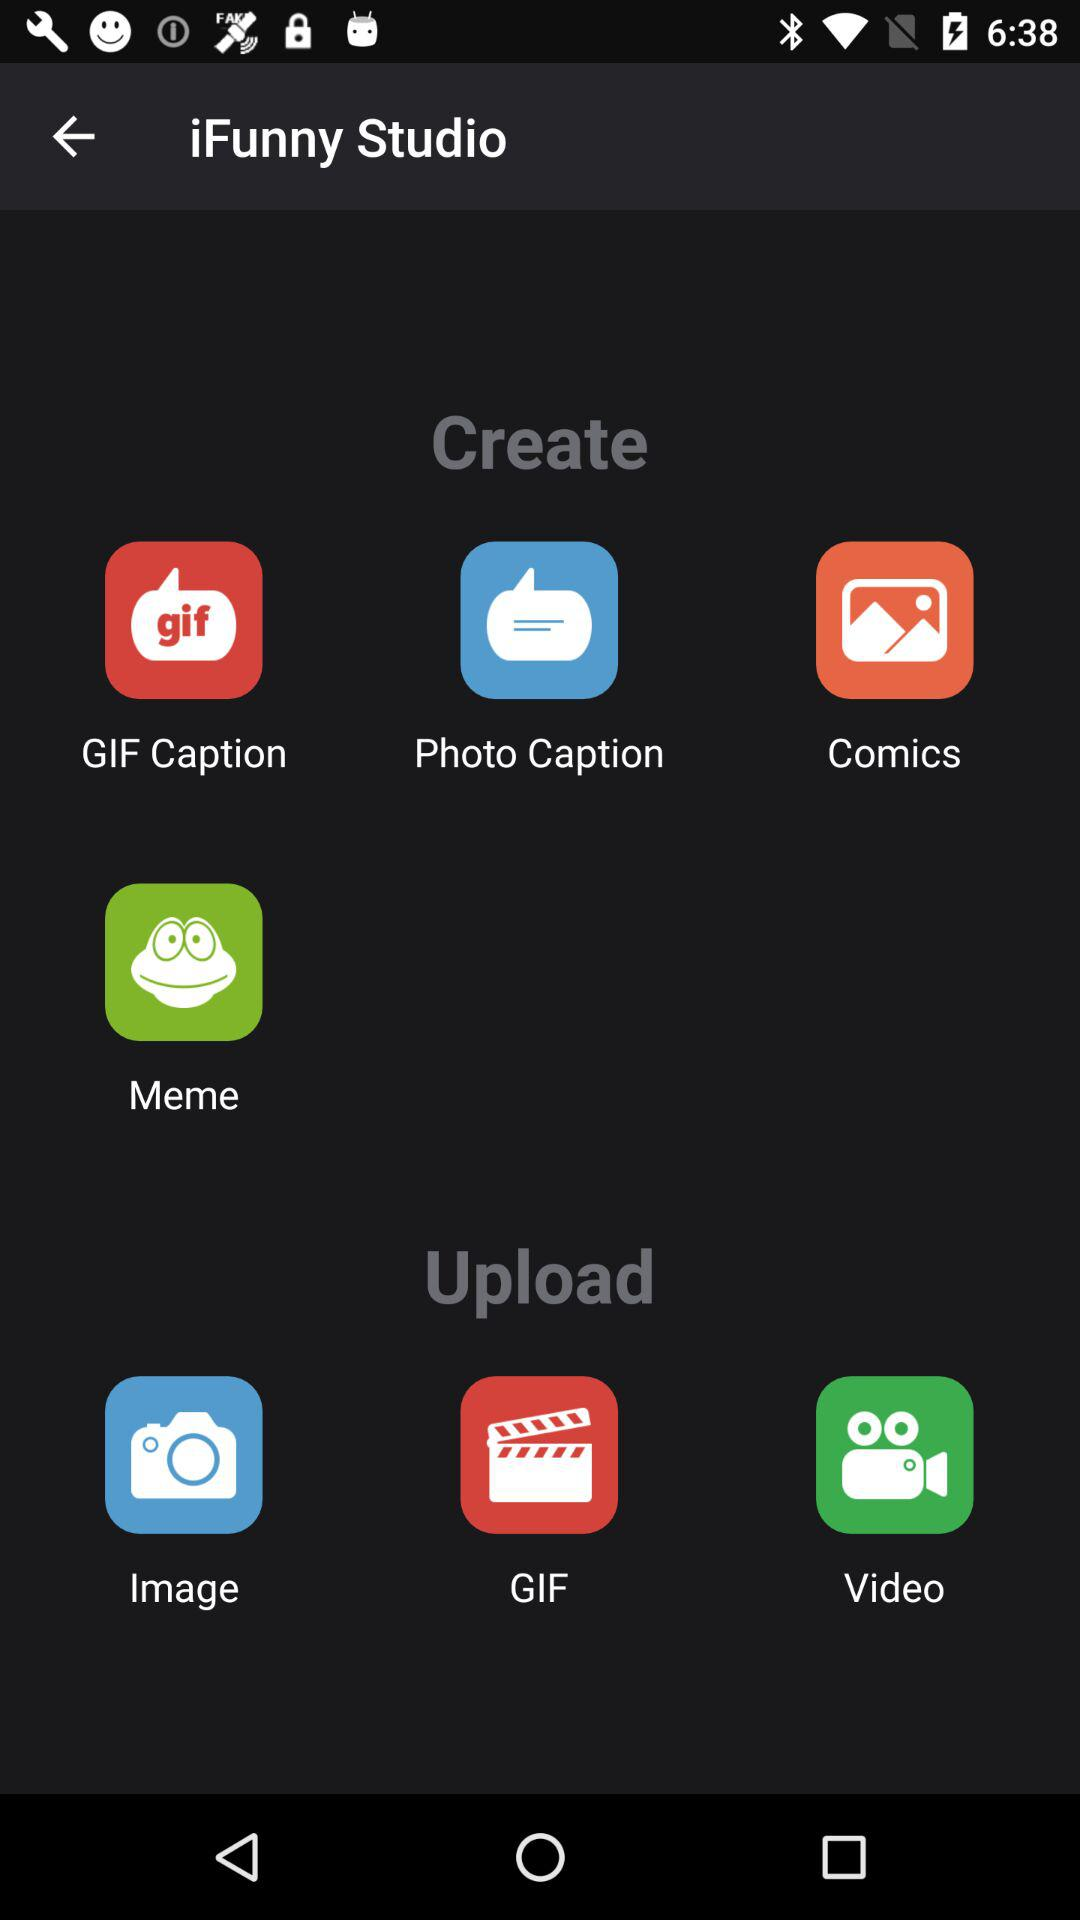What is the option for uploading? The options for uploading are "Image", "GIF" and "Video". 